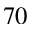<formula> <loc_0><loc_0><loc_500><loc_500>^ { 7 0 }</formula> 